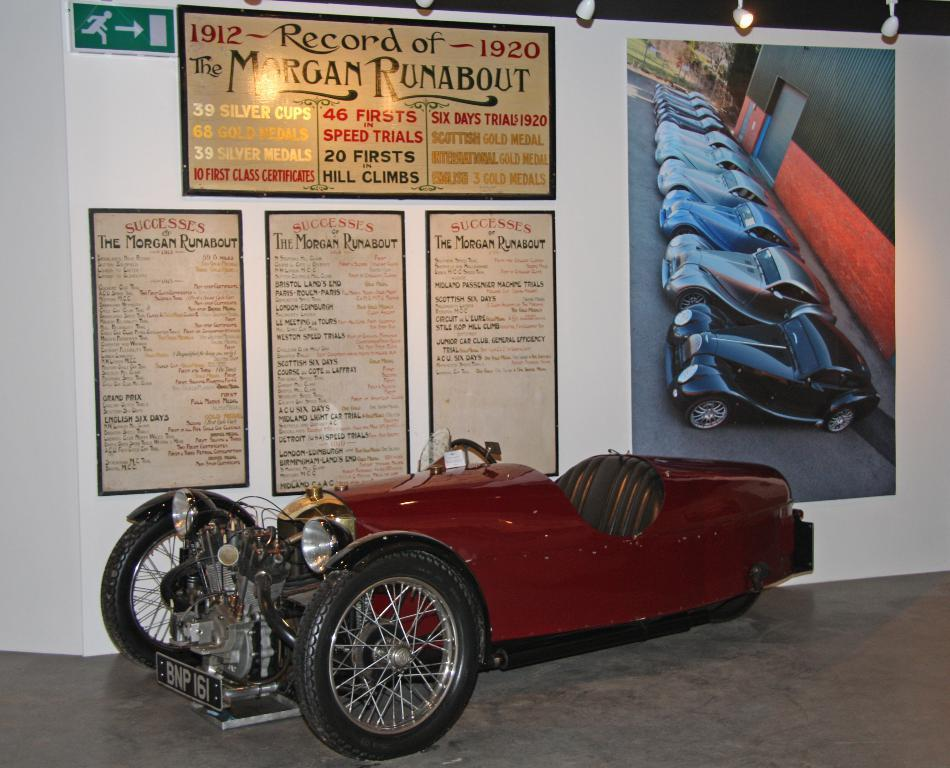What is the main subject in the image? There is a vehicle in the image. What can be seen behind the vehicle? There is a wall behind the vehicle. What is on the wall? There are posters on the wall. Can you describe the symbol in the top left corner of the image? There is an exit symbol in the top left corner of the image. What is the vehicle's desire in the image? Vehicles do not have desires, so this question cannot be answered. 